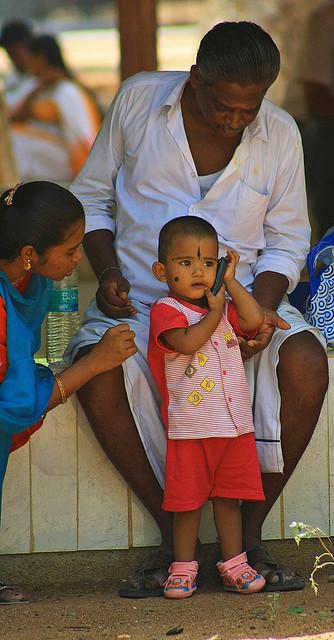What type of phone is being used? Please explain your reasoning. cellular. The phone is wireless. it does not have a rotary dial or a coin slot. 